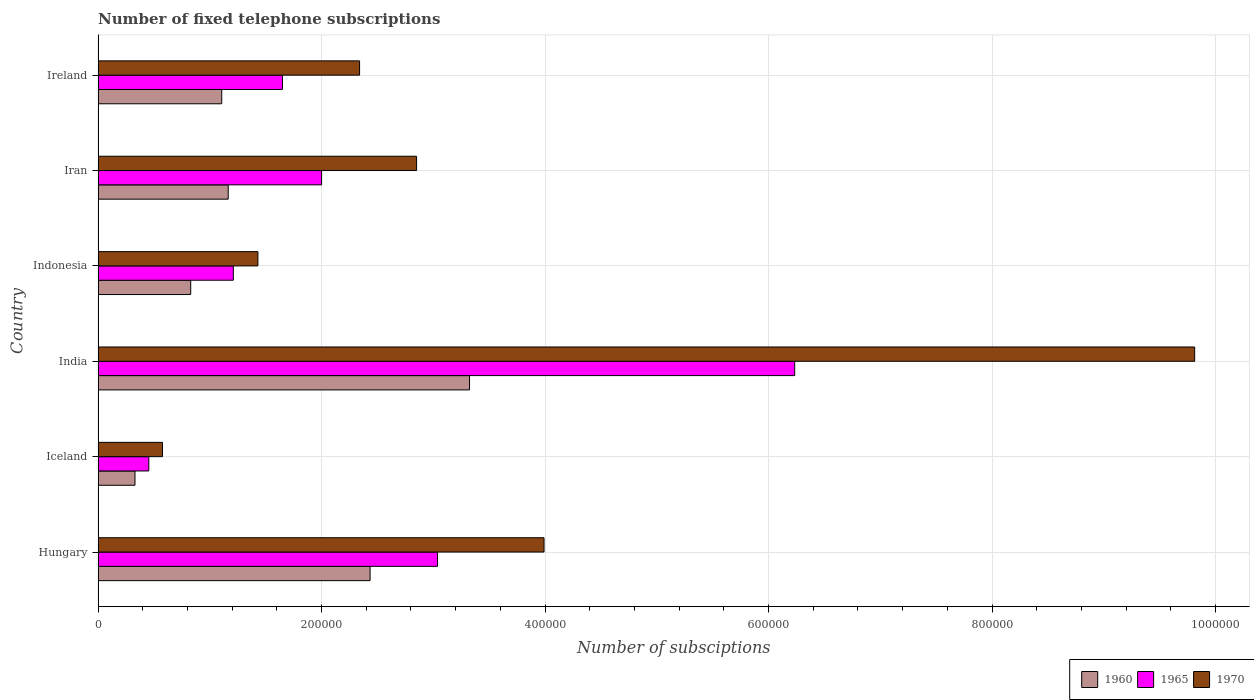How many different coloured bars are there?
Offer a very short reply. 3. How many groups of bars are there?
Provide a succinct answer. 6. Are the number of bars on each tick of the Y-axis equal?
Provide a short and direct response. Yes. How many bars are there on the 5th tick from the bottom?
Your response must be concise. 3. What is the label of the 5th group of bars from the top?
Give a very brief answer. Iceland. What is the number of fixed telephone subscriptions in 1970 in Indonesia?
Your answer should be compact. 1.43e+05. Across all countries, what is the maximum number of fixed telephone subscriptions in 1960?
Your answer should be compact. 3.32e+05. Across all countries, what is the minimum number of fixed telephone subscriptions in 1970?
Your answer should be very brief. 5.76e+04. In which country was the number of fixed telephone subscriptions in 1960 maximum?
Offer a terse response. India. What is the total number of fixed telephone subscriptions in 1960 in the graph?
Give a very brief answer. 9.19e+05. What is the difference between the number of fixed telephone subscriptions in 1970 in Hungary and that in Iran?
Offer a terse response. 1.14e+05. What is the difference between the number of fixed telephone subscriptions in 1970 in India and the number of fixed telephone subscriptions in 1960 in Ireland?
Provide a short and direct response. 8.71e+05. What is the average number of fixed telephone subscriptions in 1965 per country?
Make the answer very short. 2.43e+05. What is the difference between the number of fixed telephone subscriptions in 1965 and number of fixed telephone subscriptions in 1970 in Hungary?
Offer a terse response. -9.53e+04. In how many countries, is the number of fixed telephone subscriptions in 1965 greater than 440000 ?
Make the answer very short. 1. What is the ratio of the number of fixed telephone subscriptions in 1960 in Hungary to that in Iran?
Your answer should be very brief. 2.09. Is the number of fixed telephone subscriptions in 1960 in India less than that in Indonesia?
Your response must be concise. No. Is the difference between the number of fixed telephone subscriptions in 1965 in Hungary and Iceland greater than the difference between the number of fixed telephone subscriptions in 1970 in Hungary and Iceland?
Your answer should be very brief. No. What is the difference between the highest and the second highest number of fixed telephone subscriptions in 1960?
Your answer should be compact. 8.90e+04. What is the difference between the highest and the lowest number of fixed telephone subscriptions in 1965?
Provide a short and direct response. 5.78e+05. In how many countries, is the number of fixed telephone subscriptions in 1960 greater than the average number of fixed telephone subscriptions in 1960 taken over all countries?
Your answer should be compact. 2. What does the 2nd bar from the bottom in Iceland represents?
Provide a short and direct response. 1965. Is it the case that in every country, the sum of the number of fixed telephone subscriptions in 1970 and number of fixed telephone subscriptions in 1960 is greater than the number of fixed telephone subscriptions in 1965?
Make the answer very short. Yes. How many countries are there in the graph?
Your response must be concise. 6. Does the graph contain grids?
Provide a short and direct response. Yes. How many legend labels are there?
Provide a succinct answer. 3. What is the title of the graph?
Ensure brevity in your answer.  Number of fixed telephone subscriptions. What is the label or title of the X-axis?
Ensure brevity in your answer.  Number of subsciptions. What is the Number of subsciptions of 1960 in Hungary?
Provide a succinct answer. 2.43e+05. What is the Number of subsciptions of 1965 in Hungary?
Ensure brevity in your answer.  3.04e+05. What is the Number of subsciptions of 1970 in Hungary?
Give a very brief answer. 3.99e+05. What is the Number of subsciptions in 1960 in Iceland?
Your answer should be compact. 3.30e+04. What is the Number of subsciptions in 1965 in Iceland?
Make the answer very short. 4.54e+04. What is the Number of subsciptions in 1970 in Iceland?
Your response must be concise. 5.76e+04. What is the Number of subsciptions of 1960 in India?
Ensure brevity in your answer.  3.32e+05. What is the Number of subsciptions of 1965 in India?
Ensure brevity in your answer.  6.23e+05. What is the Number of subsciptions of 1970 in India?
Your answer should be very brief. 9.81e+05. What is the Number of subsciptions of 1960 in Indonesia?
Your answer should be compact. 8.29e+04. What is the Number of subsciptions in 1965 in Indonesia?
Ensure brevity in your answer.  1.21e+05. What is the Number of subsciptions in 1970 in Indonesia?
Make the answer very short. 1.43e+05. What is the Number of subsciptions of 1960 in Iran?
Give a very brief answer. 1.16e+05. What is the Number of subsciptions of 1970 in Iran?
Provide a succinct answer. 2.85e+05. What is the Number of subsciptions in 1960 in Ireland?
Provide a succinct answer. 1.11e+05. What is the Number of subsciptions of 1965 in Ireland?
Offer a terse response. 1.65e+05. What is the Number of subsciptions in 1970 in Ireland?
Ensure brevity in your answer.  2.34e+05. Across all countries, what is the maximum Number of subsciptions of 1960?
Your answer should be compact. 3.32e+05. Across all countries, what is the maximum Number of subsciptions in 1965?
Make the answer very short. 6.23e+05. Across all countries, what is the maximum Number of subsciptions of 1970?
Make the answer very short. 9.81e+05. Across all countries, what is the minimum Number of subsciptions in 1960?
Your response must be concise. 3.30e+04. Across all countries, what is the minimum Number of subsciptions of 1965?
Your response must be concise. 4.54e+04. Across all countries, what is the minimum Number of subsciptions in 1970?
Provide a short and direct response. 5.76e+04. What is the total Number of subsciptions of 1960 in the graph?
Give a very brief answer. 9.19e+05. What is the total Number of subsciptions in 1965 in the graph?
Offer a very short reply. 1.46e+06. What is the total Number of subsciptions of 1970 in the graph?
Provide a succinct answer. 2.10e+06. What is the difference between the Number of subsciptions of 1960 in Hungary and that in Iceland?
Keep it short and to the point. 2.10e+05. What is the difference between the Number of subsciptions in 1965 in Hungary and that in Iceland?
Offer a very short reply. 2.58e+05. What is the difference between the Number of subsciptions in 1970 in Hungary and that in Iceland?
Your answer should be very brief. 3.41e+05. What is the difference between the Number of subsciptions in 1960 in Hungary and that in India?
Provide a succinct answer. -8.90e+04. What is the difference between the Number of subsciptions of 1965 in Hungary and that in India?
Make the answer very short. -3.20e+05. What is the difference between the Number of subsciptions in 1970 in Hungary and that in India?
Ensure brevity in your answer.  -5.82e+05. What is the difference between the Number of subsciptions in 1960 in Hungary and that in Indonesia?
Give a very brief answer. 1.61e+05. What is the difference between the Number of subsciptions of 1965 in Hungary and that in Indonesia?
Your answer should be compact. 1.83e+05. What is the difference between the Number of subsciptions in 1970 in Hungary and that in Indonesia?
Provide a short and direct response. 2.56e+05. What is the difference between the Number of subsciptions of 1960 in Hungary and that in Iran?
Your response must be concise. 1.27e+05. What is the difference between the Number of subsciptions in 1965 in Hungary and that in Iran?
Provide a short and direct response. 1.04e+05. What is the difference between the Number of subsciptions of 1970 in Hungary and that in Iran?
Your answer should be compact. 1.14e+05. What is the difference between the Number of subsciptions of 1960 in Hungary and that in Ireland?
Offer a very short reply. 1.33e+05. What is the difference between the Number of subsciptions in 1965 in Hungary and that in Ireland?
Ensure brevity in your answer.  1.39e+05. What is the difference between the Number of subsciptions of 1970 in Hungary and that in Ireland?
Ensure brevity in your answer.  1.65e+05. What is the difference between the Number of subsciptions in 1960 in Iceland and that in India?
Offer a very short reply. -2.99e+05. What is the difference between the Number of subsciptions in 1965 in Iceland and that in India?
Provide a succinct answer. -5.78e+05. What is the difference between the Number of subsciptions in 1970 in Iceland and that in India?
Your response must be concise. -9.24e+05. What is the difference between the Number of subsciptions of 1960 in Iceland and that in Indonesia?
Offer a very short reply. -4.99e+04. What is the difference between the Number of subsciptions of 1965 in Iceland and that in Indonesia?
Keep it short and to the point. -7.56e+04. What is the difference between the Number of subsciptions in 1970 in Iceland and that in Indonesia?
Provide a short and direct response. -8.54e+04. What is the difference between the Number of subsciptions in 1960 in Iceland and that in Iran?
Provide a short and direct response. -8.34e+04. What is the difference between the Number of subsciptions of 1965 in Iceland and that in Iran?
Your answer should be very brief. -1.55e+05. What is the difference between the Number of subsciptions of 1970 in Iceland and that in Iran?
Offer a very short reply. -2.27e+05. What is the difference between the Number of subsciptions of 1960 in Iceland and that in Ireland?
Your response must be concise. -7.76e+04. What is the difference between the Number of subsciptions of 1965 in Iceland and that in Ireland?
Your response must be concise. -1.20e+05. What is the difference between the Number of subsciptions in 1970 in Iceland and that in Ireland?
Your answer should be compact. -1.76e+05. What is the difference between the Number of subsciptions in 1960 in India and that in Indonesia?
Provide a succinct answer. 2.50e+05. What is the difference between the Number of subsciptions in 1965 in India and that in Indonesia?
Your answer should be compact. 5.02e+05. What is the difference between the Number of subsciptions of 1970 in India and that in Indonesia?
Ensure brevity in your answer.  8.38e+05. What is the difference between the Number of subsciptions of 1960 in India and that in Iran?
Ensure brevity in your answer.  2.16e+05. What is the difference between the Number of subsciptions of 1965 in India and that in Iran?
Make the answer very short. 4.23e+05. What is the difference between the Number of subsciptions in 1970 in India and that in Iran?
Your response must be concise. 6.96e+05. What is the difference between the Number of subsciptions of 1960 in India and that in Ireland?
Offer a very short reply. 2.22e+05. What is the difference between the Number of subsciptions in 1965 in India and that in Ireland?
Keep it short and to the point. 4.58e+05. What is the difference between the Number of subsciptions of 1970 in India and that in Ireland?
Your response must be concise. 7.47e+05. What is the difference between the Number of subsciptions of 1960 in Indonesia and that in Iran?
Keep it short and to the point. -3.36e+04. What is the difference between the Number of subsciptions in 1965 in Indonesia and that in Iran?
Your answer should be very brief. -7.90e+04. What is the difference between the Number of subsciptions of 1970 in Indonesia and that in Iran?
Provide a short and direct response. -1.42e+05. What is the difference between the Number of subsciptions in 1960 in Indonesia and that in Ireland?
Keep it short and to the point. -2.78e+04. What is the difference between the Number of subsciptions in 1965 in Indonesia and that in Ireland?
Your answer should be very brief. -4.40e+04. What is the difference between the Number of subsciptions of 1970 in Indonesia and that in Ireland?
Provide a succinct answer. -9.10e+04. What is the difference between the Number of subsciptions of 1960 in Iran and that in Ireland?
Make the answer very short. 5792. What is the difference between the Number of subsciptions of 1965 in Iran and that in Ireland?
Your response must be concise. 3.50e+04. What is the difference between the Number of subsciptions in 1970 in Iran and that in Ireland?
Make the answer very short. 5.10e+04. What is the difference between the Number of subsciptions of 1960 in Hungary and the Number of subsciptions of 1965 in Iceland?
Ensure brevity in your answer.  1.98e+05. What is the difference between the Number of subsciptions of 1960 in Hungary and the Number of subsciptions of 1970 in Iceland?
Your response must be concise. 1.86e+05. What is the difference between the Number of subsciptions in 1965 in Hungary and the Number of subsciptions in 1970 in Iceland?
Ensure brevity in your answer.  2.46e+05. What is the difference between the Number of subsciptions in 1960 in Hungary and the Number of subsciptions in 1965 in India?
Offer a very short reply. -3.80e+05. What is the difference between the Number of subsciptions in 1960 in Hungary and the Number of subsciptions in 1970 in India?
Offer a terse response. -7.38e+05. What is the difference between the Number of subsciptions of 1965 in Hungary and the Number of subsciptions of 1970 in India?
Your answer should be very brief. -6.78e+05. What is the difference between the Number of subsciptions of 1960 in Hungary and the Number of subsciptions of 1965 in Indonesia?
Your answer should be very brief. 1.22e+05. What is the difference between the Number of subsciptions of 1960 in Hungary and the Number of subsciptions of 1970 in Indonesia?
Offer a very short reply. 1.00e+05. What is the difference between the Number of subsciptions in 1965 in Hungary and the Number of subsciptions in 1970 in Indonesia?
Provide a succinct answer. 1.61e+05. What is the difference between the Number of subsciptions in 1960 in Hungary and the Number of subsciptions in 1965 in Iran?
Give a very brief answer. 4.34e+04. What is the difference between the Number of subsciptions of 1960 in Hungary and the Number of subsciptions of 1970 in Iran?
Your response must be concise. -4.16e+04. What is the difference between the Number of subsciptions of 1965 in Hungary and the Number of subsciptions of 1970 in Iran?
Keep it short and to the point. 1.88e+04. What is the difference between the Number of subsciptions in 1960 in Hungary and the Number of subsciptions in 1965 in Ireland?
Offer a terse response. 7.84e+04. What is the difference between the Number of subsciptions in 1960 in Hungary and the Number of subsciptions in 1970 in Ireland?
Make the answer very short. 9400. What is the difference between the Number of subsciptions of 1965 in Hungary and the Number of subsciptions of 1970 in Ireland?
Keep it short and to the point. 6.98e+04. What is the difference between the Number of subsciptions of 1960 in Iceland and the Number of subsciptions of 1965 in India?
Make the answer very short. -5.90e+05. What is the difference between the Number of subsciptions in 1960 in Iceland and the Number of subsciptions in 1970 in India?
Give a very brief answer. -9.48e+05. What is the difference between the Number of subsciptions in 1965 in Iceland and the Number of subsciptions in 1970 in India?
Offer a very short reply. -9.36e+05. What is the difference between the Number of subsciptions of 1960 in Iceland and the Number of subsciptions of 1965 in Indonesia?
Your response must be concise. -8.80e+04. What is the difference between the Number of subsciptions of 1965 in Iceland and the Number of subsciptions of 1970 in Indonesia?
Make the answer very short. -9.76e+04. What is the difference between the Number of subsciptions in 1960 in Iceland and the Number of subsciptions in 1965 in Iran?
Your answer should be compact. -1.67e+05. What is the difference between the Number of subsciptions of 1960 in Iceland and the Number of subsciptions of 1970 in Iran?
Offer a very short reply. -2.52e+05. What is the difference between the Number of subsciptions in 1965 in Iceland and the Number of subsciptions in 1970 in Iran?
Give a very brief answer. -2.40e+05. What is the difference between the Number of subsciptions in 1960 in Iceland and the Number of subsciptions in 1965 in Ireland?
Make the answer very short. -1.32e+05. What is the difference between the Number of subsciptions of 1960 in Iceland and the Number of subsciptions of 1970 in Ireland?
Make the answer very short. -2.01e+05. What is the difference between the Number of subsciptions in 1965 in Iceland and the Number of subsciptions in 1970 in Ireland?
Ensure brevity in your answer.  -1.89e+05. What is the difference between the Number of subsciptions of 1960 in India and the Number of subsciptions of 1965 in Indonesia?
Keep it short and to the point. 2.11e+05. What is the difference between the Number of subsciptions in 1960 in India and the Number of subsciptions in 1970 in Indonesia?
Offer a terse response. 1.89e+05. What is the difference between the Number of subsciptions of 1965 in India and the Number of subsciptions of 1970 in Indonesia?
Make the answer very short. 4.80e+05. What is the difference between the Number of subsciptions in 1960 in India and the Number of subsciptions in 1965 in Iran?
Make the answer very short. 1.32e+05. What is the difference between the Number of subsciptions of 1960 in India and the Number of subsciptions of 1970 in Iran?
Your answer should be very brief. 4.74e+04. What is the difference between the Number of subsciptions in 1965 in India and the Number of subsciptions in 1970 in Iran?
Make the answer very short. 3.38e+05. What is the difference between the Number of subsciptions of 1960 in India and the Number of subsciptions of 1965 in Ireland?
Make the answer very short. 1.67e+05. What is the difference between the Number of subsciptions in 1960 in India and the Number of subsciptions in 1970 in Ireland?
Your response must be concise. 9.84e+04. What is the difference between the Number of subsciptions in 1965 in India and the Number of subsciptions in 1970 in Ireland?
Provide a short and direct response. 3.89e+05. What is the difference between the Number of subsciptions in 1960 in Indonesia and the Number of subsciptions in 1965 in Iran?
Your response must be concise. -1.17e+05. What is the difference between the Number of subsciptions of 1960 in Indonesia and the Number of subsciptions of 1970 in Iran?
Ensure brevity in your answer.  -2.02e+05. What is the difference between the Number of subsciptions in 1965 in Indonesia and the Number of subsciptions in 1970 in Iran?
Your response must be concise. -1.64e+05. What is the difference between the Number of subsciptions in 1960 in Indonesia and the Number of subsciptions in 1965 in Ireland?
Make the answer very short. -8.21e+04. What is the difference between the Number of subsciptions of 1960 in Indonesia and the Number of subsciptions of 1970 in Ireland?
Ensure brevity in your answer.  -1.51e+05. What is the difference between the Number of subsciptions in 1965 in Indonesia and the Number of subsciptions in 1970 in Ireland?
Your response must be concise. -1.13e+05. What is the difference between the Number of subsciptions in 1960 in Iran and the Number of subsciptions in 1965 in Ireland?
Offer a very short reply. -4.86e+04. What is the difference between the Number of subsciptions of 1960 in Iran and the Number of subsciptions of 1970 in Ireland?
Your response must be concise. -1.18e+05. What is the difference between the Number of subsciptions of 1965 in Iran and the Number of subsciptions of 1970 in Ireland?
Your answer should be compact. -3.40e+04. What is the average Number of subsciptions in 1960 per country?
Make the answer very short. 1.53e+05. What is the average Number of subsciptions of 1965 per country?
Offer a terse response. 2.43e+05. What is the average Number of subsciptions of 1970 per country?
Your answer should be very brief. 3.50e+05. What is the difference between the Number of subsciptions in 1960 and Number of subsciptions in 1965 in Hungary?
Give a very brief answer. -6.04e+04. What is the difference between the Number of subsciptions in 1960 and Number of subsciptions in 1970 in Hungary?
Make the answer very short. -1.56e+05. What is the difference between the Number of subsciptions of 1965 and Number of subsciptions of 1970 in Hungary?
Keep it short and to the point. -9.53e+04. What is the difference between the Number of subsciptions of 1960 and Number of subsciptions of 1965 in Iceland?
Your answer should be very brief. -1.24e+04. What is the difference between the Number of subsciptions of 1960 and Number of subsciptions of 1970 in Iceland?
Your answer should be very brief. -2.46e+04. What is the difference between the Number of subsciptions in 1965 and Number of subsciptions in 1970 in Iceland?
Make the answer very short. -1.22e+04. What is the difference between the Number of subsciptions in 1960 and Number of subsciptions in 1965 in India?
Keep it short and to the point. -2.91e+05. What is the difference between the Number of subsciptions of 1960 and Number of subsciptions of 1970 in India?
Keep it short and to the point. -6.49e+05. What is the difference between the Number of subsciptions of 1965 and Number of subsciptions of 1970 in India?
Keep it short and to the point. -3.58e+05. What is the difference between the Number of subsciptions of 1960 and Number of subsciptions of 1965 in Indonesia?
Your answer should be compact. -3.81e+04. What is the difference between the Number of subsciptions of 1960 and Number of subsciptions of 1970 in Indonesia?
Make the answer very short. -6.01e+04. What is the difference between the Number of subsciptions in 1965 and Number of subsciptions in 1970 in Indonesia?
Your answer should be very brief. -2.20e+04. What is the difference between the Number of subsciptions in 1960 and Number of subsciptions in 1965 in Iran?
Give a very brief answer. -8.36e+04. What is the difference between the Number of subsciptions of 1960 and Number of subsciptions of 1970 in Iran?
Make the answer very short. -1.69e+05. What is the difference between the Number of subsciptions in 1965 and Number of subsciptions in 1970 in Iran?
Offer a terse response. -8.50e+04. What is the difference between the Number of subsciptions in 1960 and Number of subsciptions in 1965 in Ireland?
Offer a terse response. -5.44e+04. What is the difference between the Number of subsciptions in 1960 and Number of subsciptions in 1970 in Ireland?
Ensure brevity in your answer.  -1.23e+05. What is the difference between the Number of subsciptions in 1965 and Number of subsciptions in 1970 in Ireland?
Your answer should be compact. -6.90e+04. What is the ratio of the Number of subsciptions in 1960 in Hungary to that in Iceland?
Make the answer very short. 7.38. What is the ratio of the Number of subsciptions of 1965 in Hungary to that in Iceland?
Your answer should be very brief. 6.7. What is the ratio of the Number of subsciptions of 1970 in Hungary to that in Iceland?
Give a very brief answer. 6.93. What is the ratio of the Number of subsciptions of 1960 in Hungary to that in India?
Offer a very short reply. 0.73. What is the ratio of the Number of subsciptions in 1965 in Hungary to that in India?
Keep it short and to the point. 0.49. What is the ratio of the Number of subsciptions in 1970 in Hungary to that in India?
Keep it short and to the point. 0.41. What is the ratio of the Number of subsciptions in 1960 in Hungary to that in Indonesia?
Provide a succinct answer. 2.94. What is the ratio of the Number of subsciptions of 1965 in Hungary to that in Indonesia?
Give a very brief answer. 2.51. What is the ratio of the Number of subsciptions in 1970 in Hungary to that in Indonesia?
Give a very brief answer. 2.79. What is the ratio of the Number of subsciptions of 1960 in Hungary to that in Iran?
Your answer should be very brief. 2.09. What is the ratio of the Number of subsciptions of 1965 in Hungary to that in Iran?
Provide a succinct answer. 1.52. What is the ratio of the Number of subsciptions of 1970 in Hungary to that in Iran?
Provide a short and direct response. 1.4. What is the ratio of the Number of subsciptions in 1960 in Hungary to that in Ireland?
Offer a terse response. 2.2. What is the ratio of the Number of subsciptions in 1965 in Hungary to that in Ireland?
Give a very brief answer. 1.84. What is the ratio of the Number of subsciptions of 1970 in Hungary to that in Ireland?
Ensure brevity in your answer.  1.71. What is the ratio of the Number of subsciptions of 1960 in Iceland to that in India?
Your answer should be compact. 0.1. What is the ratio of the Number of subsciptions in 1965 in Iceland to that in India?
Keep it short and to the point. 0.07. What is the ratio of the Number of subsciptions of 1970 in Iceland to that in India?
Provide a succinct answer. 0.06. What is the ratio of the Number of subsciptions of 1960 in Iceland to that in Indonesia?
Provide a short and direct response. 0.4. What is the ratio of the Number of subsciptions in 1965 in Iceland to that in Indonesia?
Give a very brief answer. 0.37. What is the ratio of the Number of subsciptions in 1970 in Iceland to that in Indonesia?
Offer a very short reply. 0.4. What is the ratio of the Number of subsciptions of 1960 in Iceland to that in Iran?
Offer a terse response. 0.28. What is the ratio of the Number of subsciptions in 1965 in Iceland to that in Iran?
Ensure brevity in your answer.  0.23. What is the ratio of the Number of subsciptions of 1970 in Iceland to that in Iran?
Provide a short and direct response. 0.2. What is the ratio of the Number of subsciptions in 1960 in Iceland to that in Ireland?
Give a very brief answer. 0.3. What is the ratio of the Number of subsciptions of 1965 in Iceland to that in Ireland?
Give a very brief answer. 0.27. What is the ratio of the Number of subsciptions of 1970 in Iceland to that in Ireland?
Offer a terse response. 0.25. What is the ratio of the Number of subsciptions in 1960 in India to that in Indonesia?
Your answer should be compact. 4.01. What is the ratio of the Number of subsciptions of 1965 in India to that in Indonesia?
Offer a terse response. 5.15. What is the ratio of the Number of subsciptions of 1970 in India to that in Indonesia?
Your answer should be very brief. 6.86. What is the ratio of the Number of subsciptions in 1960 in India to that in Iran?
Offer a very short reply. 2.86. What is the ratio of the Number of subsciptions of 1965 in India to that in Iran?
Offer a very short reply. 3.12. What is the ratio of the Number of subsciptions in 1970 in India to that in Iran?
Ensure brevity in your answer.  3.44. What is the ratio of the Number of subsciptions of 1960 in India to that in Ireland?
Make the answer very short. 3. What is the ratio of the Number of subsciptions of 1965 in India to that in Ireland?
Make the answer very short. 3.78. What is the ratio of the Number of subsciptions of 1970 in India to that in Ireland?
Offer a terse response. 4.19. What is the ratio of the Number of subsciptions of 1960 in Indonesia to that in Iran?
Ensure brevity in your answer.  0.71. What is the ratio of the Number of subsciptions of 1965 in Indonesia to that in Iran?
Offer a terse response. 0.6. What is the ratio of the Number of subsciptions in 1970 in Indonesia to that in Iran?
Provide a succinct answer. 0.5. What is the ratio of the Number of subsciptions in 1960 in Indonesia to that in Ireland?
Offer a very short reply. 0.75. What is the ratio of the Number of subsciptions of 1965 in Indonesia to that in Ireland?
Your answer should be very brief. 0.73. What is the ratio of the Number of subsciptions of 1970 in Indonesia to that in Ireland?
Your answer should be very brief. 0.61. What is the ratio of the Number of subsciptions of 1960 in Iran to that in Ireland?
Your answer should be compact. 1.05. What is the ratio of the Number of subsciptions of 1965 in Iran to that in Ireland?
Offer a terse response. 1.21. What is the ratio of the Number of subsciptions of 1970 in Iran to that in Ireland?
Make the answer very short. 1.22. What is the difference between the highest and the second highest Number of subsciptions of 1960?
Offer a very short reply. 8.90e+04. What is the difference between the highest and the second highest Number of subsciptions in 1965?
Your response must be concise. 3.20e+05. What is the difference between the highest and the second highest Number of subsciptions in 1970?
Your response must be concise. 5.82e+05. What is the difference between the highest and the lowest Number of subsciptions in 1960?
Your answer should be compact. 2.99e+05. What is the difference between the highest and the lowest Number of subsciptions in 1965?
Keep it short and to the point. 5.78e+05. What is the difference between the highest and the lowest Number of subsciptions of 1970?
Keep it short and to the point. 9.24e+05. 